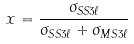<formula> <loc_0><loc_0><loc_500><loc_500>x = \frac { \sigma _ { S S 3 \ell } } { \sigma _ { S S 3 \ell } + \sigma _ { M S 3 \ell } }</formula> 